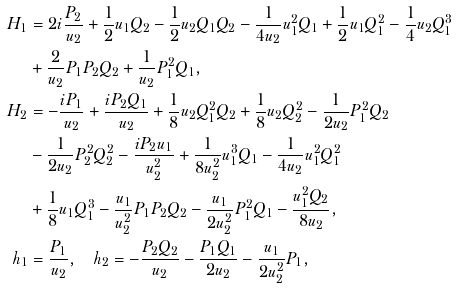<formula> <loc_0><loc_0><loc_500><loc_500>H _ { 1 } & = 2 i \frac { P _ { 2 } } { u _ { 2 } } + \frac { 1 } { 2 } u _ { 1 } Q _ { 2 } - \frac { 1 } { 2 } u _ { 2 } Q _ { 1 } Q _ { 2 } - \frac { 1 } { 4 u _ { 2 } } u _ { 1 } ^ { 2 } Q _ { 1 } + \frac { 1 } { 2 } u _ { 1 } Q _ { 1 } ^ { 2 } - \frac { 1 } { 4 } u _ { 2 } Q _ { 1 } ^ { 3 } \\ & + \frac { 2 } { u _ { 2 } } P _ { 1 } P _ { 2 } Q _ { 2 } + \frac { 1 } { u _ { 2 } } P _ { 1 } ^ { 2 } Q _ { 1 } , \\ H _ { 2 } & = - \frac { i P _ { 1 } } { u _ { 2 } } + \frac { i P _ { 2 } Q _ { 1 } } { u _ { 2 } } + \frac { 1 } { 8 } u _ { 2 } Q _ { 1 } ^ { 2 } Q _ { 2 } + \frac { 1 } { 8 } u _ { 2 } Q _ { 2 } ^ { 2 } - \frac { 1 } { 2 u _ { 2 } } P _ { 1 } ^ { 2 } Q _ { 2 } \\ & - \frac { 1 } { 2 u _ { 2 } } P _ { 2 } ^ { 2 } Q _ { 2 } ^ { 2 } - \frac { i P _ { 2 } u _ { 1 } } { u _ { 2 } ^ { 2 } } + \frac { 1 } { 8 u _ { 2 } ^ { 2 } } u _ { 1 } ^ { 3 } Q _ { 1 } - \frac { 1 } { 4 u _ { 2 } } u _ { 1 } ^ { 2 } Q _ { 1 } ^ { 2 } \\ & + \frac { 1 } { 8 } u _ { 1 } Q _ { 1 } ^ { 3 } - \frac { u _ { 1 } } { u _ { 2 } ^ { 2 } } P _ { 1 } P _ { 2 } Q _ { 2 } - \frac { u _ { 1 } } { 2 u _ { 2 } ^ { 2 } } P _ { 1 } ^ { 2 } Q _ { 1 } - \frac { u _ { 1 } ^ { 2 } Q _ { 2 } } { 8 u _ { 2 } } , \\ h _ { 1 } & = \frac { P _ { 1 } } { u _ { 2 } } , \quad h _ { 2 } = - \frac { P _ { 2 } Q _ { 2 } } { u _ { 2 } } - \frac { P _ { 1 } Q _ { 1 } } { 2 u _ { 2 } } - \frac { u _ { 1 } } { 2 u _ { 2 } ^ { 2 } } P _ { 1 } ,</formula> 